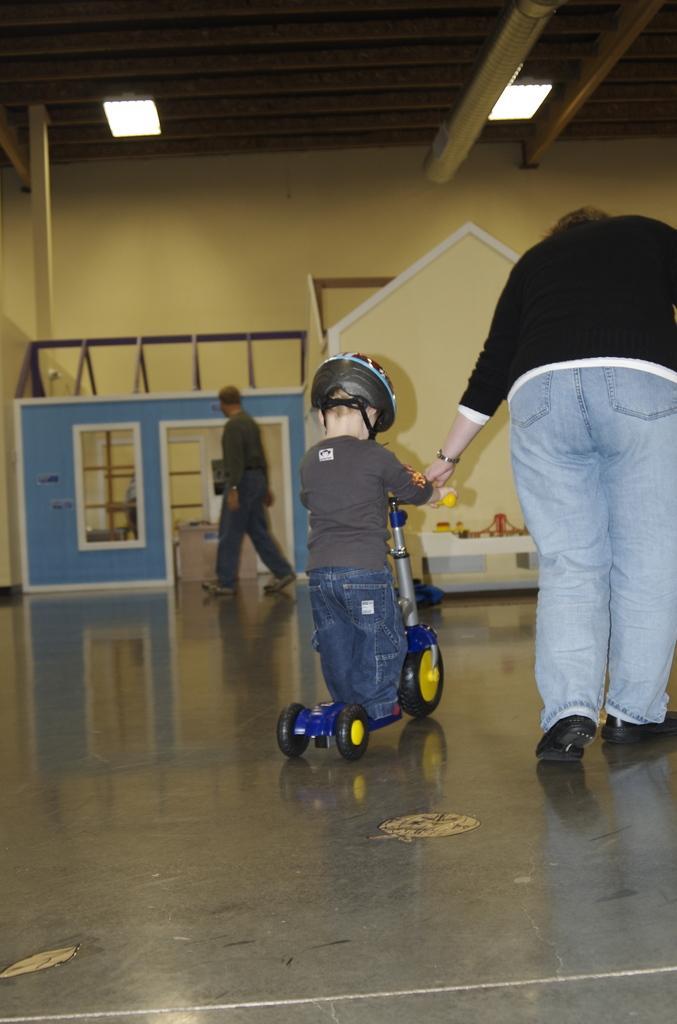Can you describe this image briefly? In this image we can see three persons, a kid is riding on the skate scooter, he is wearing a helmet, there are huts, lights, also we can see the wall, and the roof. 